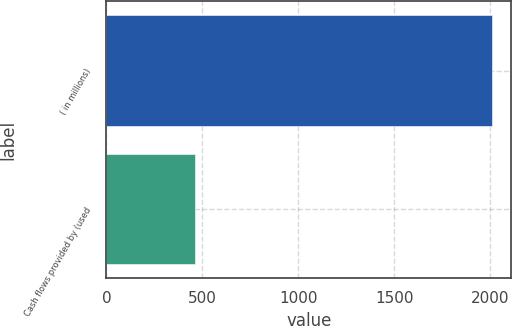Convert chart. <chart><loc_0><loc_0><loc_500><loc_500><bar_chart><fcel>( in millions)<fcel>Cash flows provided by (used<nl><fcel>2010<fcel>459.6<nl></chart> 